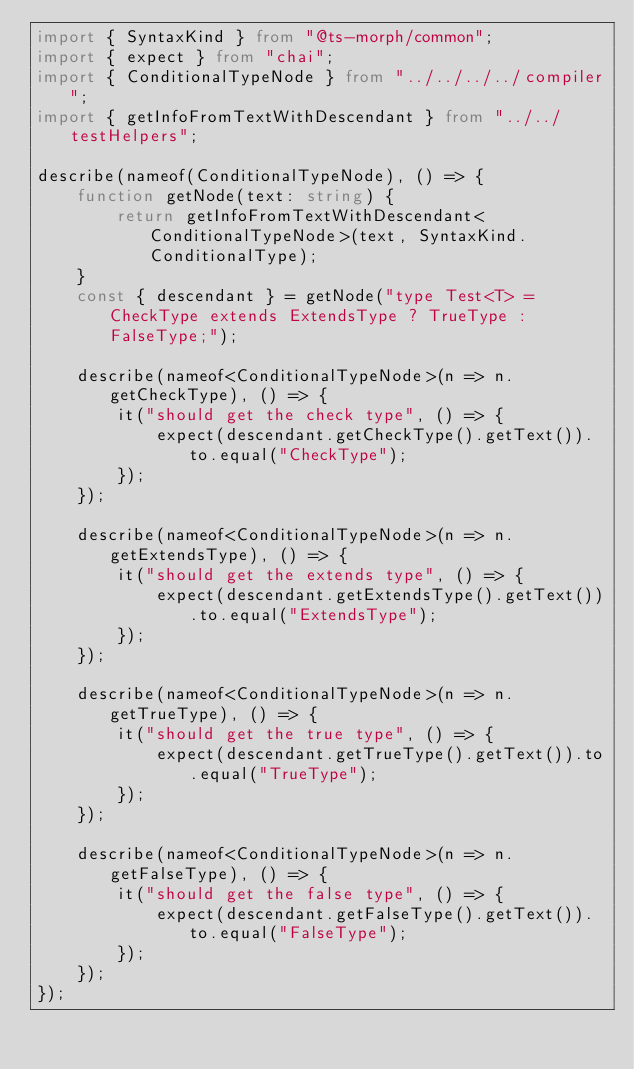Convert code to text. <code><loc_0><loc_0><loc_500><loc_500><_TypeScript_>import { SyntaxKind } from "@ts-morph/common";
import { expect } from "chai";
import { ConditionalTypeNode } from "../../../../compiler";
import { getInfoFromTextWithDescendant } from "../../testHelpers";

describe(nameof(ConditionalTypeNode), () => {
    function getNode(text: string) {
        return getInfoFromTextWithDescendant<ConditionalTypeNode>(text, SyntaxKind.ConditionalType);
    }
    const { descendant } = getNode("type Test<T> = CheckType extends ExtendsType ? TrueType : FalseType;");

    describe(nameof<ConditionalTypeNode>(n => n.getCheckType), () => {
        it("should get the check type", () => {
            expect(descendant.getCheckType().getText()).to.equal("CheckType");
        });
    });

    describe(nameof<ConditionalTypeNode>(n => n.getExtendsType), () => {
        it("should get the extends type", () => {
            expect(descendant.getExtendsType().getText()).to.equal("ExtendsType");
        });
    });

    describe(nameof<ConditionalTypeNode>(n => n.getTrueType), () => {
        it("should get the true type", () => {
            expect(descendant.getTrueType().getText()).to.equal("TrueType");
        });
    });

    describe(nameof<ConditionalTypeNode>(n => n.getFalseType), () => {
        it("should get the false type", () => {
            expect(descendant.getFalseType().getText()).to.equal("FalseType");
        });
    });
});
</code> 